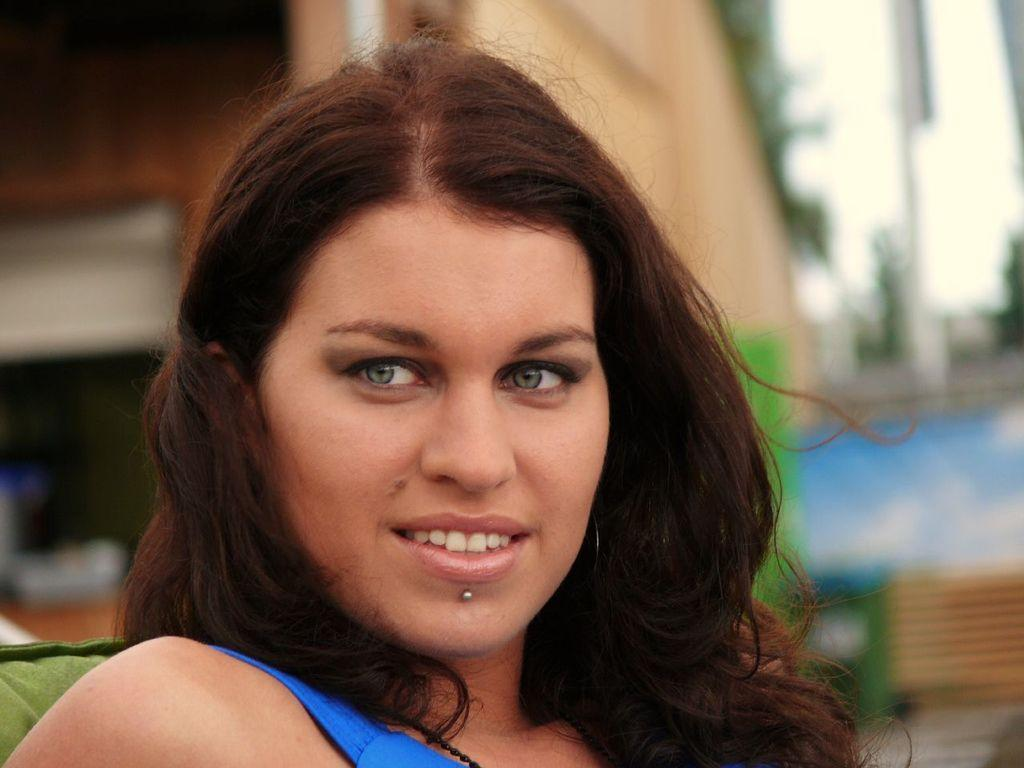Who is present in the image? There is a woman in the image. What is the woman's facial expression? The woman is smiling. What can be seen in the background of the image? There is a building, trees, and a bench in the background of the image. How would you describe the background of the image? The background appears blurry. What type of hammer is the woman using to sort pears in the image? There is no hammer or pears present in the image. The woman is simply smiling, and there is no indication of any sorting or hammer-related activity. 